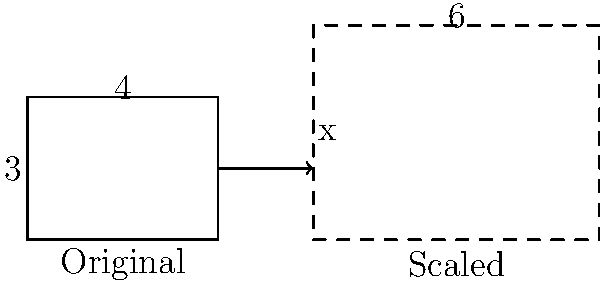As a streaming platform reviewer, you're analyzing the scaling of video thumbnails for different device screens. A rectangular thumbnail with dimensions 4 units by 3 units needs to be scaled up so that its width becomes 6 units. What will be the height ($x$) of the scaled thumbnail to maintain the aspect ratio? To solve this problem, we need to understand the concept of maintaining aspect ratio when scaling an image. Here's a step-by-step explanation:

1) The original thumbnail has dimensions 4 units (width) by 3 units (height).
   The aspect ratio is 4:3.

2) When scaling, we need to maintain this aspect ratio. This means that the ratio of the new dimensions should be the same as the original.

3) We know that the new width is 6 units. Let's call the new height $x$.

4) We can set up a proportion:
   $$\frac{\text{original width}}{\text{original height}} = \frac{\text{new width}}{\text{new height}}$$

5) Substituting the known values:
   $$\frac{4}{3} = \frac{6}{x}$$

6) Cross multiply:
   $$4x = 18$$

7) Solve for $x$:
   $$x = \frac{18}{4} = 4.5$$

Therefore, the height of the scaled thumbnail will be 4.5 units.
Answer: 4.5 units 